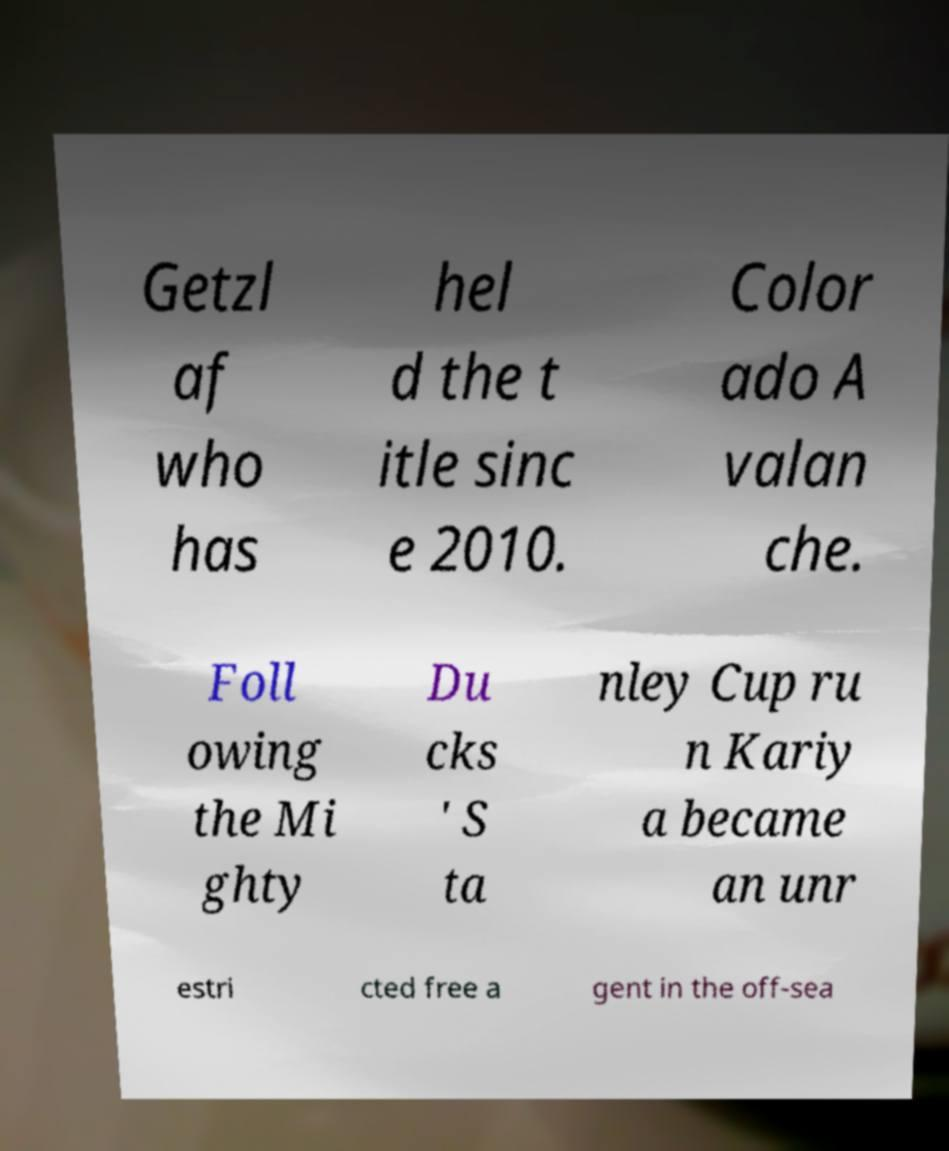I need the written content from this picture converted into text. Can you do that? Getzl af who has hel d the t itle sinc e 2010. Color ado A valan che. Foll owing the Mi ghty Du cks ' S ta nley Cup ru n Kariy a became an unr estri cted free a gent in the off-sea 